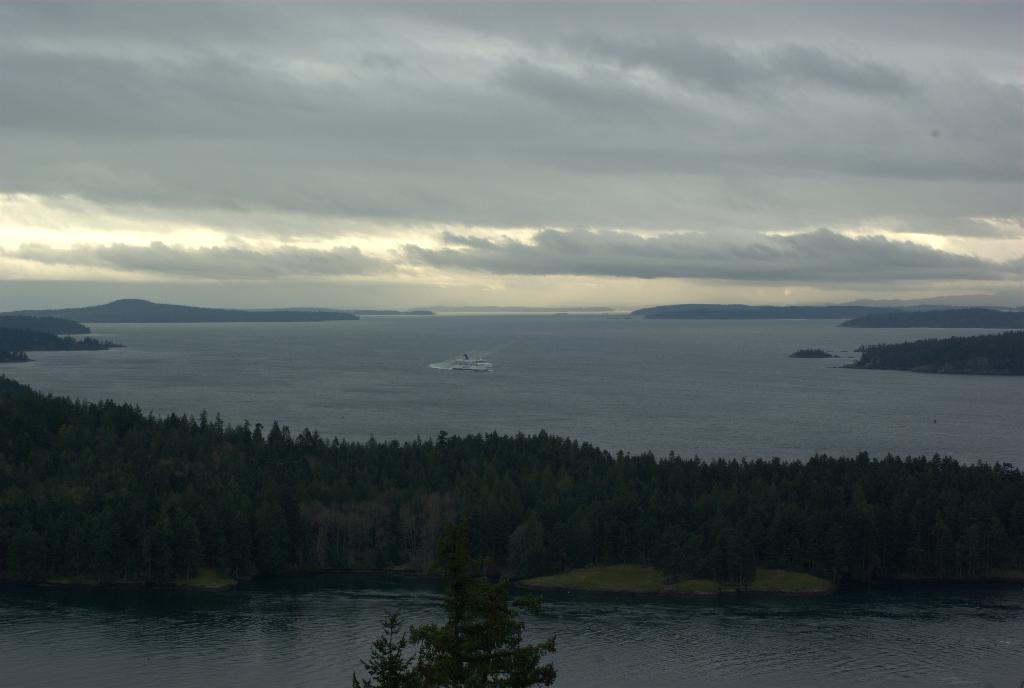In one or two sentences, can you explain what this image depicts? In this image I can see water in the front. There are trees in the center and there is a ship on the water. There are mountains at the back. There are clouds in the sky. 